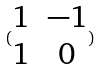Convert formula to latex. <formula><loc_0><loc_0><loc_500><loc_500>( \begin{matrix} 1 & - 1 \\ 1 & 0 \end{matrix} )</formula> 